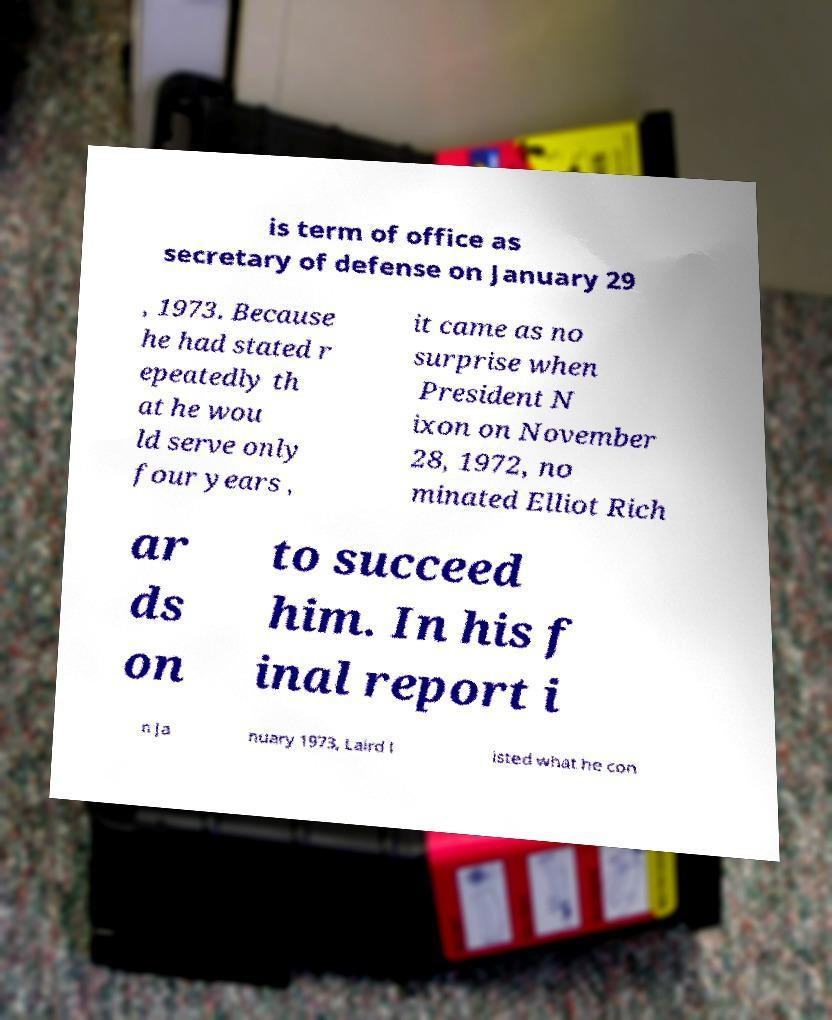Please read and relay the text visible in this image. What does it say? is term of office as secretary of defense on January 29 , 1973. Because he had stated r epeatedly th at he wou ld serve only four years , it came as no surprise when President N ixon on November 28, 1972, no minated Elliot Rich ar ds on to succeed him. In his f inal report i n Ja nuary 1973, Laird l isted what he con 